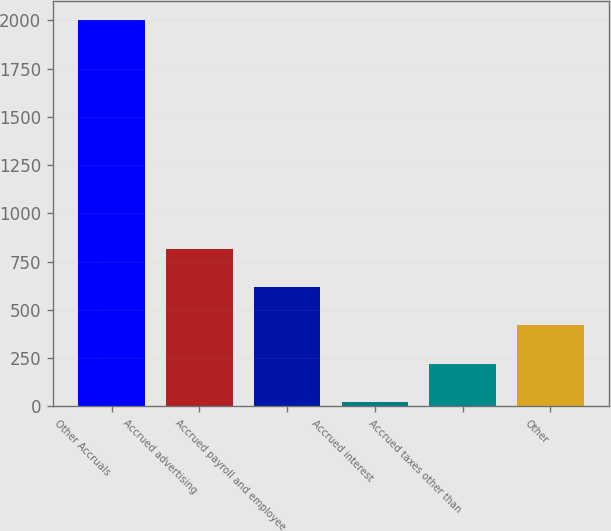Convert chart. <chart><loc_0><loc_0><loc_500><loc_500><bar_chart><fcel>Other Accruals<fcel>Accrued advertising<fcel>Accrued payroll and employee<fcel>Accrued interest<fcel>Accrued taxes other than<fcel>Other<nl><fcel>2001<fcel>814.74<fcel>617.03<fcel>23.9<fcel>221.61<fcel>419.32<nl></chart> 